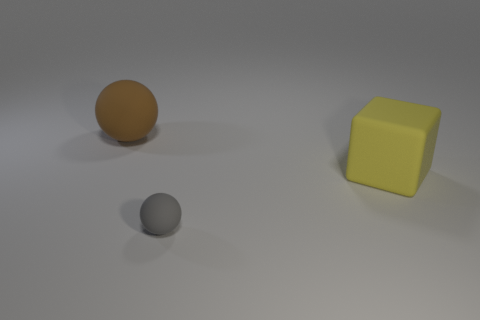What is the material of the object behind the yellow cube?
Provide a succinct answer. Rubber. Is there anything else that is the same size as the brown ball?
Provide a short and direct response. Yes. There is a large brown matte thing; are there any brown things in front of it?
Your response must be concise. No. What is the shape of the tiny gray thing?
Offer a very short reply. Sphere. What number of objects are either objects left of the gray matte ball or large metallic cylinders?
Offer a very short reply. 1. What number of other objects are there of the same color as the tiny object?
Offer a terse response. 0. There is a small sphere; is its color the same as the large thing on the left side of the tiny matte thing?
Your response must be concise. No. What color is the tiny matte thing that is the same shape as the large brown thing?
Your answer should be compact. Gray. Is the small ball made of the same material as the large object that is to the right of the brown rubber ball?
Provide a short and direct response. Yes. What is the color of the rubber block?
Your response must be concise. Yellow. 